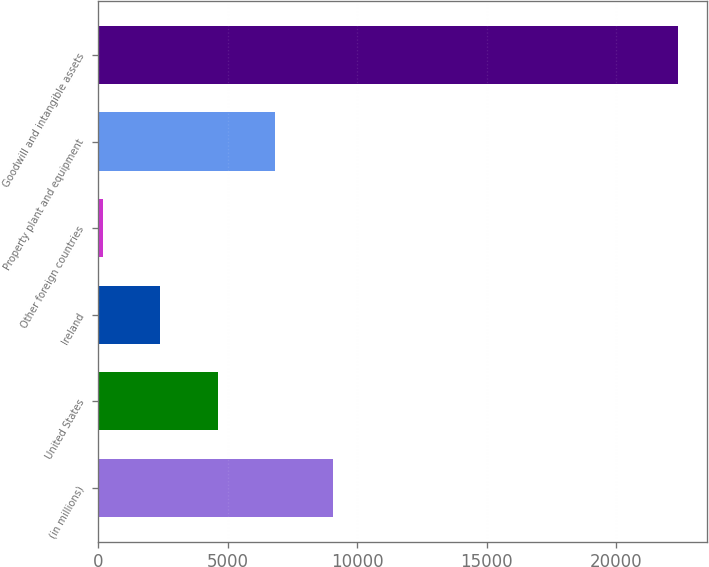Convert chart. <chart><loc_0><loc_0><loc_500><loc_500><bar_chart><fcel>(in millions)<fcel>United States<fcel>Ireland<fcel>Other foreign countries<fcel>Property plant and equipment<fcel>Goodwill and intangible assets<nl><fcel>9056.2<fcel>4615.6<fcel>2395.3<fcel>175<fcel>6835.9<fcel>22378<nl></chart> 